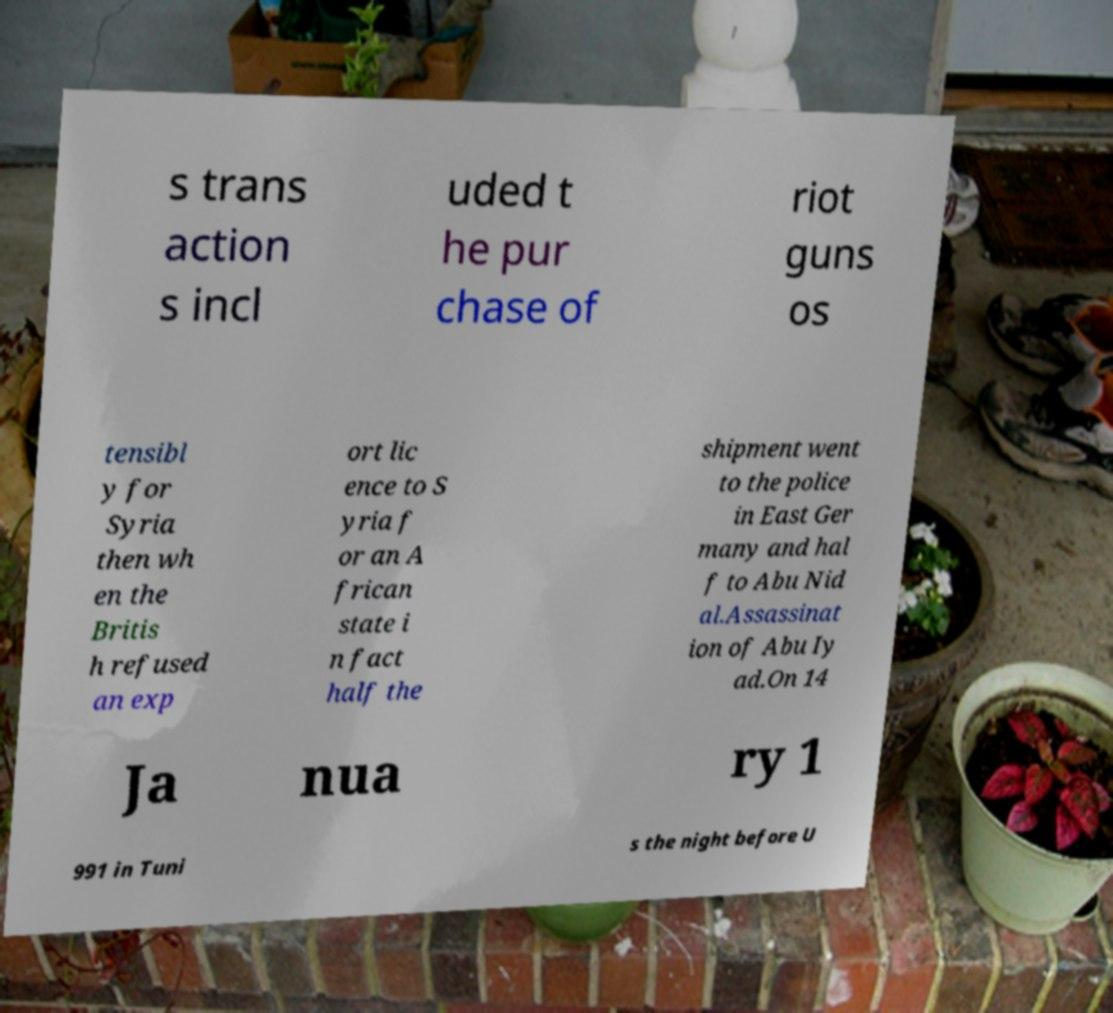For documentation purposes, I need the text within this image transcribed. Could you provide that? s trans action s incl uded t he pur chase of riot guns os tensibl y for Syria then wh en the Britis h refused an exp ort lic ence to S yria f or an A frican state i n fact half the shipment went to the police in East Ger many and hal f to Abu Nid al.Assassinat ion of Abu Iy ad.On 14 Ja nua ry 1 991 in Tuni s the night before U 